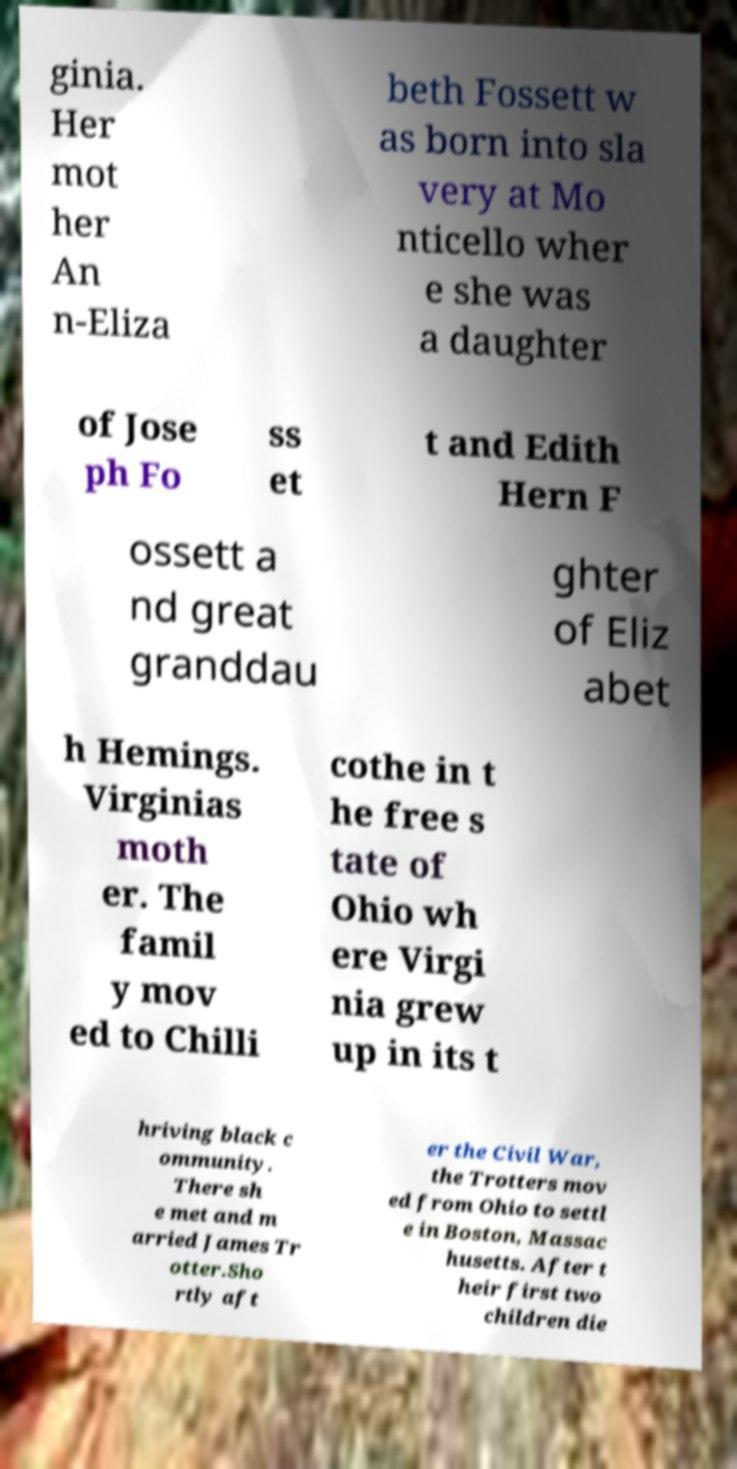For documentation purposes, I need the text within this image transcribed. Could you provide that? ginia. Her mot her An n-Eliza beth Fossett w as born into sla very at Mo nticello wher e she was a daughter of Jose ph Fo ss et t and Edith Hern F ossett a nd great granddau ghter of Eliz abet h Hemings. Virginias moth er. The famil y mov ed to Chilli cothe in t he free s tate of Ohio wh ere Virgi nia grew up in its t hriving black c ommunity. There sh e met and m arried James Tr otter.Sho rtly aft er the Civil War, the Trotters mov ed from Ohio to settl e in Boston, Massac husetts. After t heir first two children die 